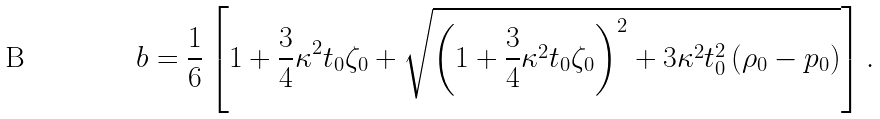<formula> <loc_0><loc_0><loc_500><loc_500>b = \frac { 1 } { 6 } \left [ 1 + \frac { 3 } { 4 } \kappa ^ { 2 } t _ { 0 } \zeta _ { 0 } + \sqrt { \left ( 1 + \frac { 3 } { 4 } \kappa ^ { 2 } t _ { 0 } \zeta _ { 0 } \right ) ^ { 2 } + 3 \kappa ^ { 2 } t _ { 0 } ^ { 2 } \, ( \rho _ { 0 } - p _ { 0 } ) } \right ] .</formula> 